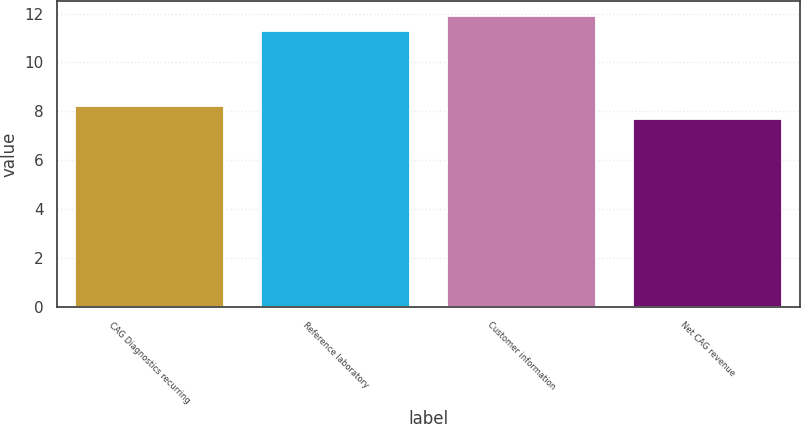Convert chart. <chart><loc_0><loc_0><loc_500><loc_500><bar_chart><fcel>CAG Diagnostics recurring<fcel>Reference laboratory<fcel>Customer information<fcel>Net CAG revenue<nl><fcel>8.2<fcel>11.3<fcel>11.9<fcel>7.7<nl></chart> 